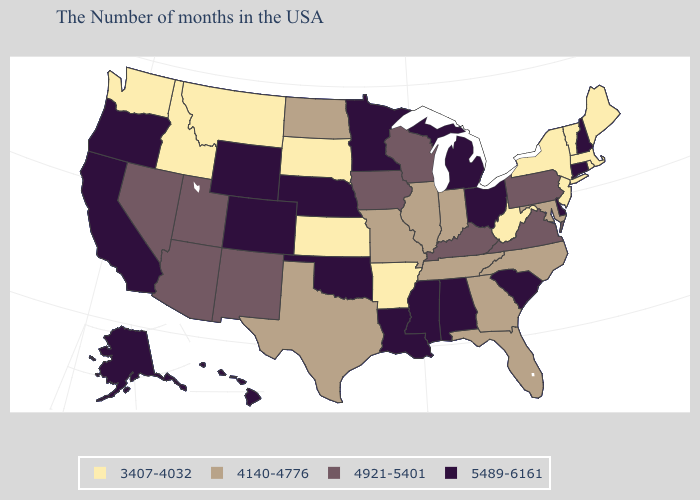Does the first symbol in the legend represent the smallest category?
Keep it brief. Yes. What is the highest value in states that border South Dakota?
Concise answer only. 5489-6161. What is the value of Nebraska?
Short answer required. 5489-6161. Among the states that border West Virginia , does Ohio have the lowest value?
Answer briefly. No. Does New Jersey have the lowest value in the Northeast?
Keep it brief. Yes. Name the states that have a value in the range 4921-5401?
Be succinct. Pennsylvania, Virginia, Kentucky, Wisconsin, Iowa, New Mexico, Utah, Arizona, Nevada. What is the value of Michigan?
Concise answer only. 5489-6161. Name the states that have a value in the range 4140-4776?
Write a very short answer. Maryland, North Carolina, Florida, Georgia, Indiana, Tennessee, Illinois, Missouri, Texas, North Dakota. Which states have the lowest value in the USA?
Write a very short answer. Maine, Massachusetts, Rhode Island, Vermont, New York, New Jersey, West Virginia, Arkansas, Kansas, South Dakota, Montana, Idaho, Washington. Name the states that have a value in the range 4921-5401?
Quick response, please. Pennsylvania, Virginia, Kentucky, Wisconsin, Iowa, New Mexico, Utah, Arizona, Nevada. Is the legend a continuous bar?
Give a very brief answer. No. Among the states that border South Carolina , which have the lowest value?
Keep it brief. North Carolina, Georgia. Does New Hampshire have the same value as Missouri?
Concise answer only. No. Does Alabama have the highest value in the USA?
Quick response, please. Yes. 